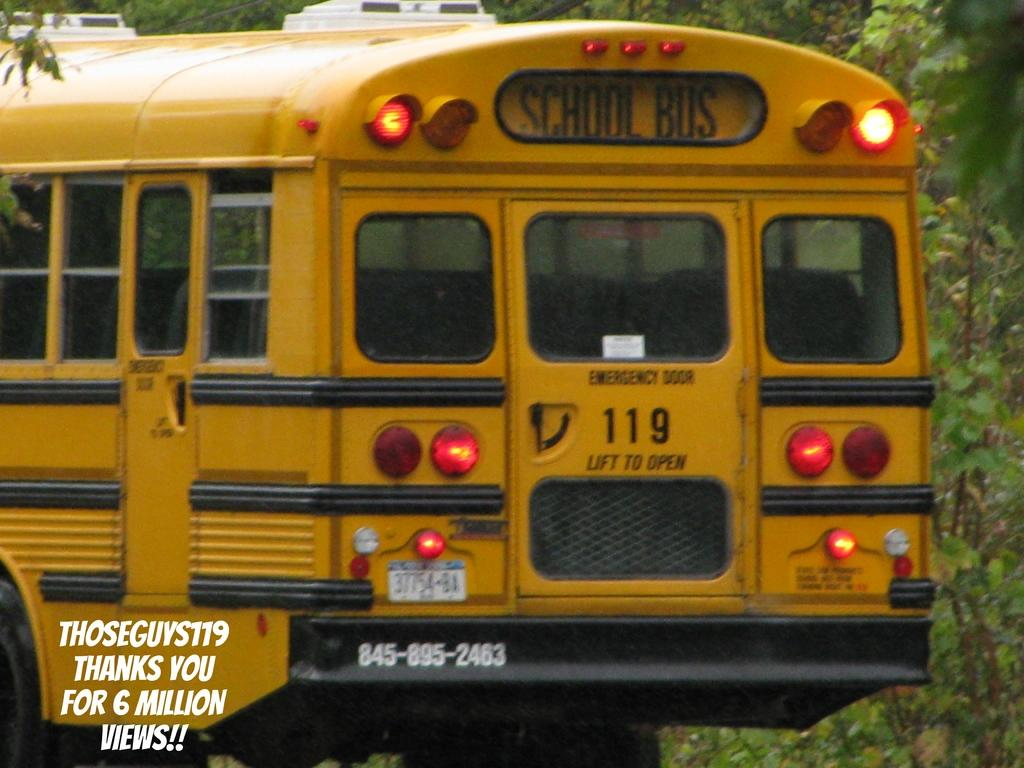What can be seen in the background of the image? There are trees in the background of the image. What is the main subject of the image? The main focus of the image is a yellow school bus. Is there any text present in the image? Yes, there is text present in the bottom left corner of the image. What type of ink is being used to write the text in the image? There is no indication of ink being used in the image, as the text appears to be part of the image itself and not written on it. Is the school bus being crushed by any objects in the image? No, the school bus is not being crushed by any objects in the image; it is depicted as a normal, undamaged vehicle. 